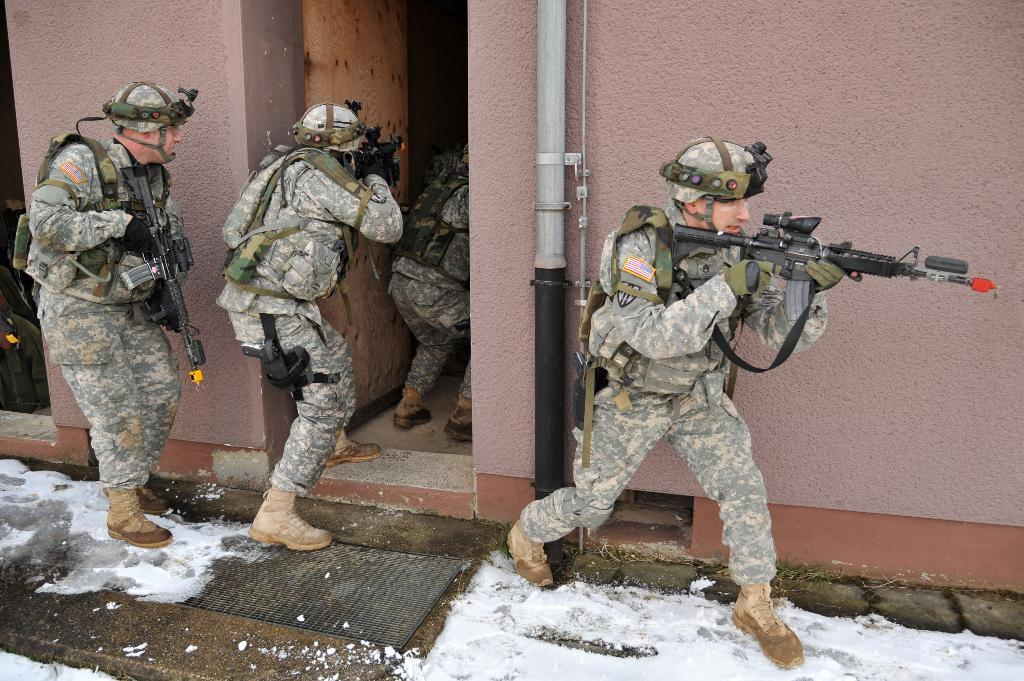What are the men in the image wearing? The men in the image are wearing army uniforms. What type of headgear are the men wearing? The men are wearing caps on their heads. What are the men holding in their hands? The men are holding guns in their hands. What can be seen in the background of the image? There is a wall visible in the background of the image. What is attached to the wall in the image? There is a pipe on the wall. What type of jam is being spread on the lizards in the image? There are no lizards or jam present in the image; it features men in army uniforms holding guns. 